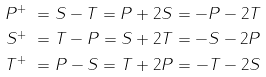Convert formula to latex. <formula><loc_0><loc_0><loc_500><loc_500>P ^ { + } & \ = S - T = P + 2 S = - P - 2 T \\ S ^ { + } & \ = T - P = S + 2 T = - S - 2 P \\ T ^ { + } & \ = P - S = T + 2 P = - T - 2 S</formula> 